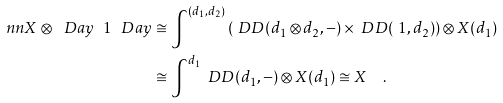<formula> <loc_0><loc_0><loc_500><loc_500>\ n n X \otimes _ { \ } D a y \ 1 _ { \ } D a y & \cong \int ^ { ( d _ { 1 } , d _ { 2 } ) } \left ( \ D D ( d _ { 1 } \otimes d _ { 2 } , - ) \times \ D D ( \ 1 , d _ { 2 } ) \right ) \otimes X ( d _ { 1 } ) \\ & \cong \int ^ { d _ { 1 } } \ D D ( d _ { 1 } , - ) \otimes X ( d _ { 1 } ) \cong X \quad .</formula> 